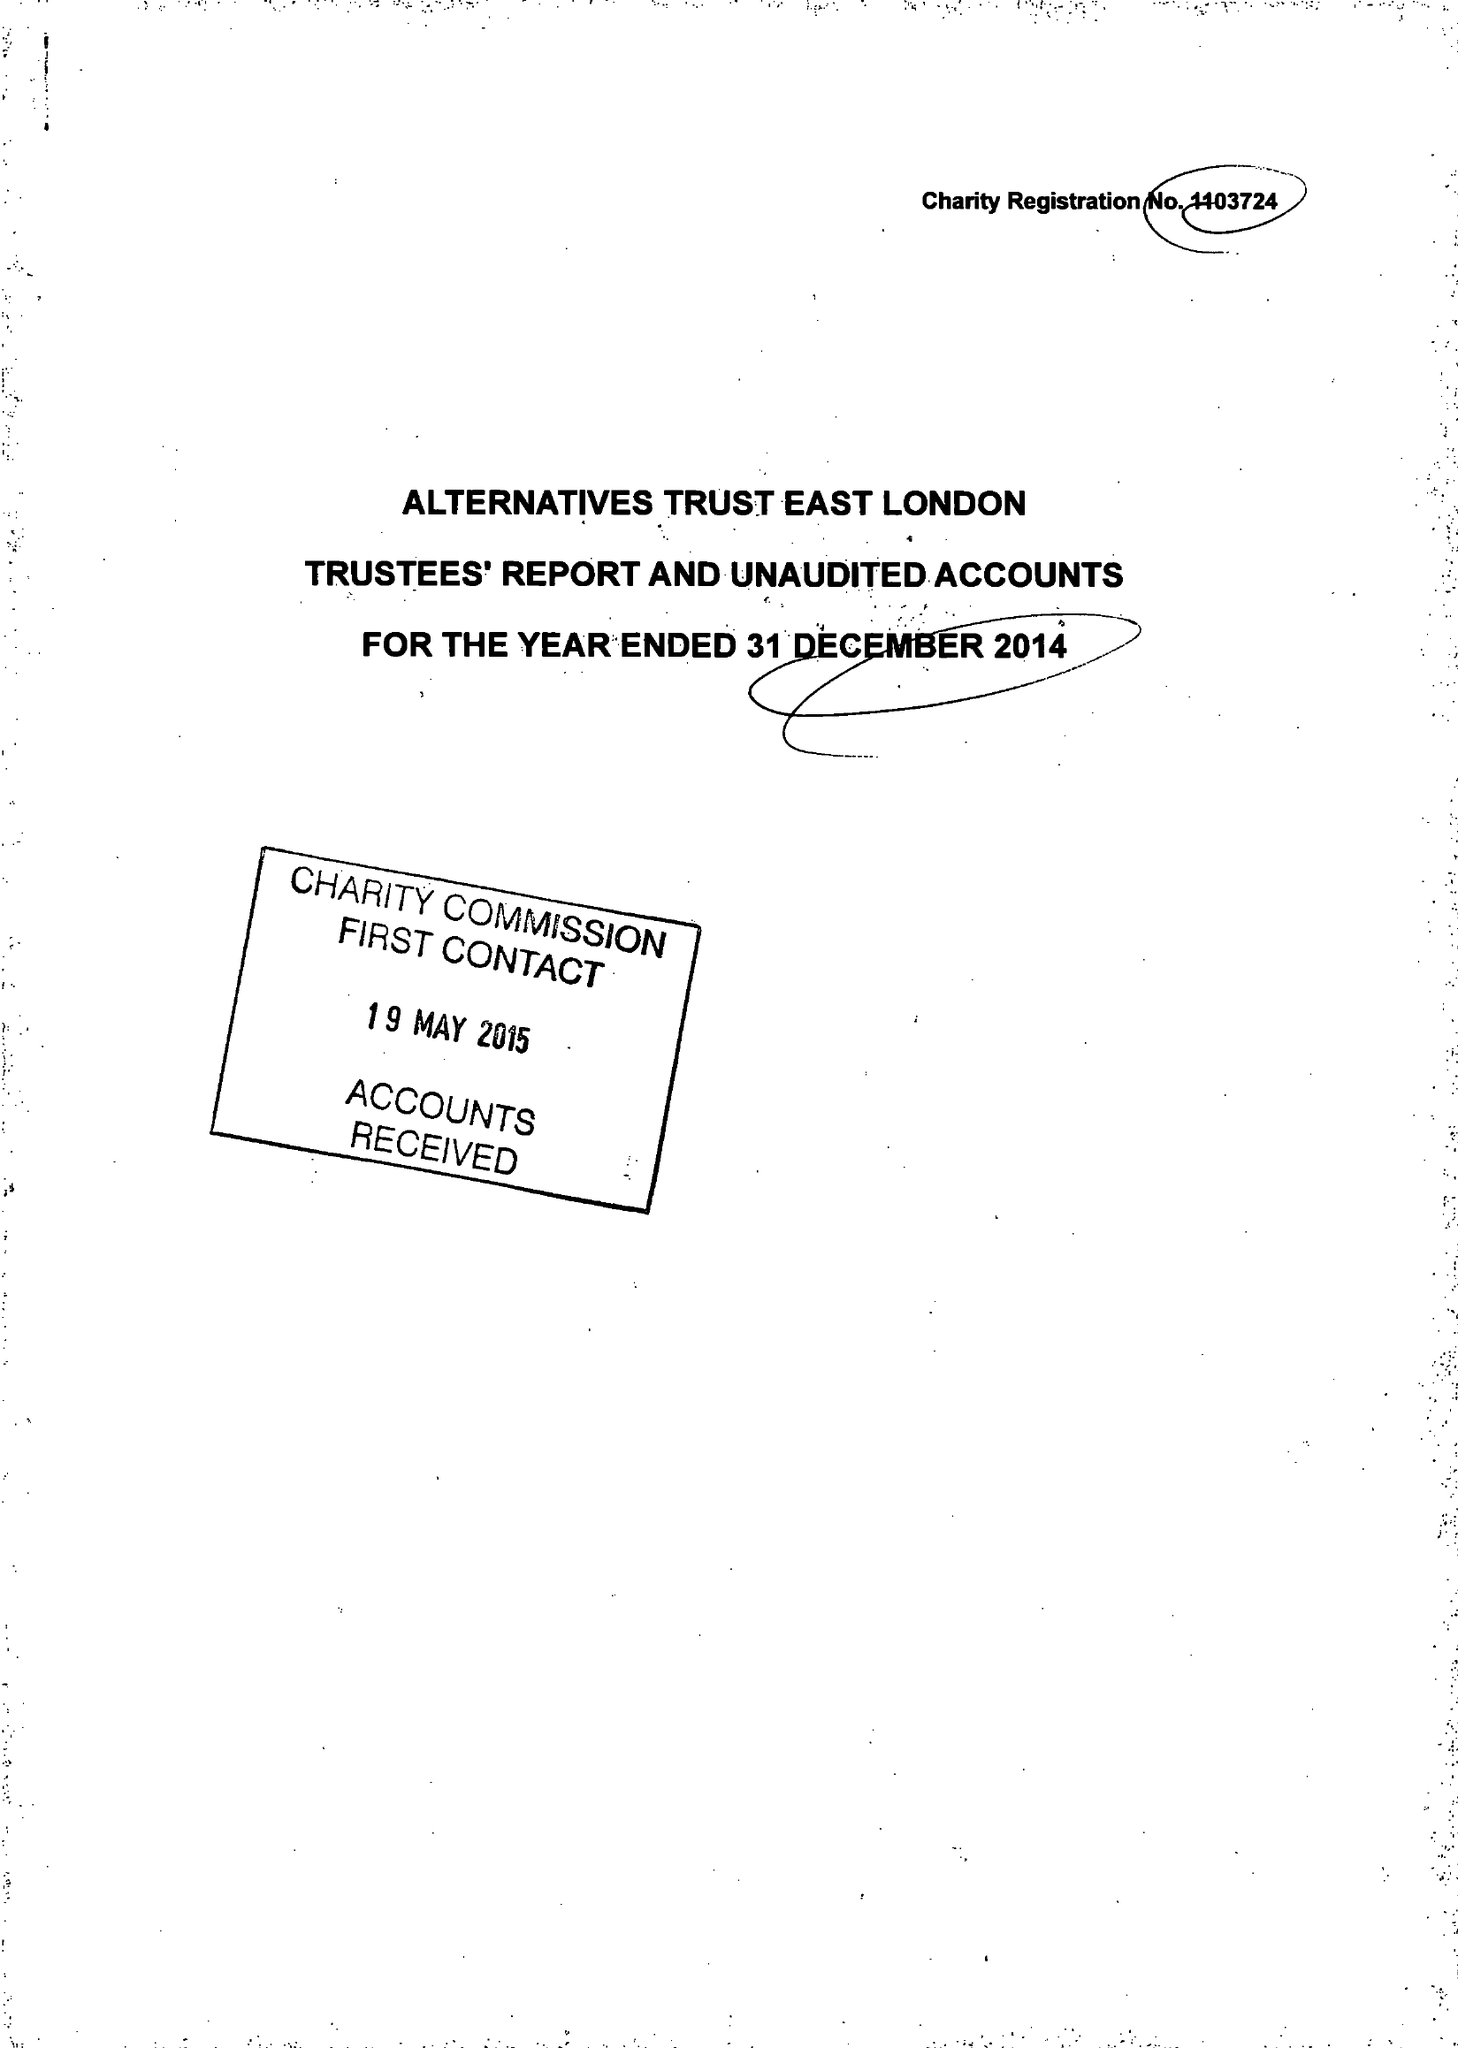What is the value for the address__post_town?
Answer the question using a single word or phrase. LONDON 